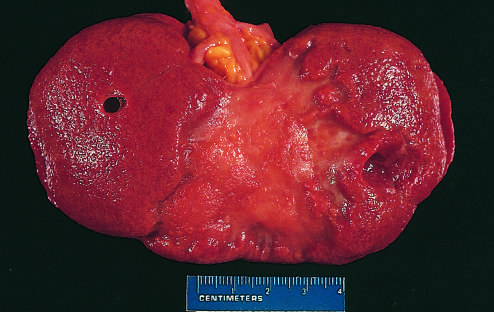how is the remote kidney infarct replaced?
Answer the question using a single word or phrase. By a large fibrotic scar 